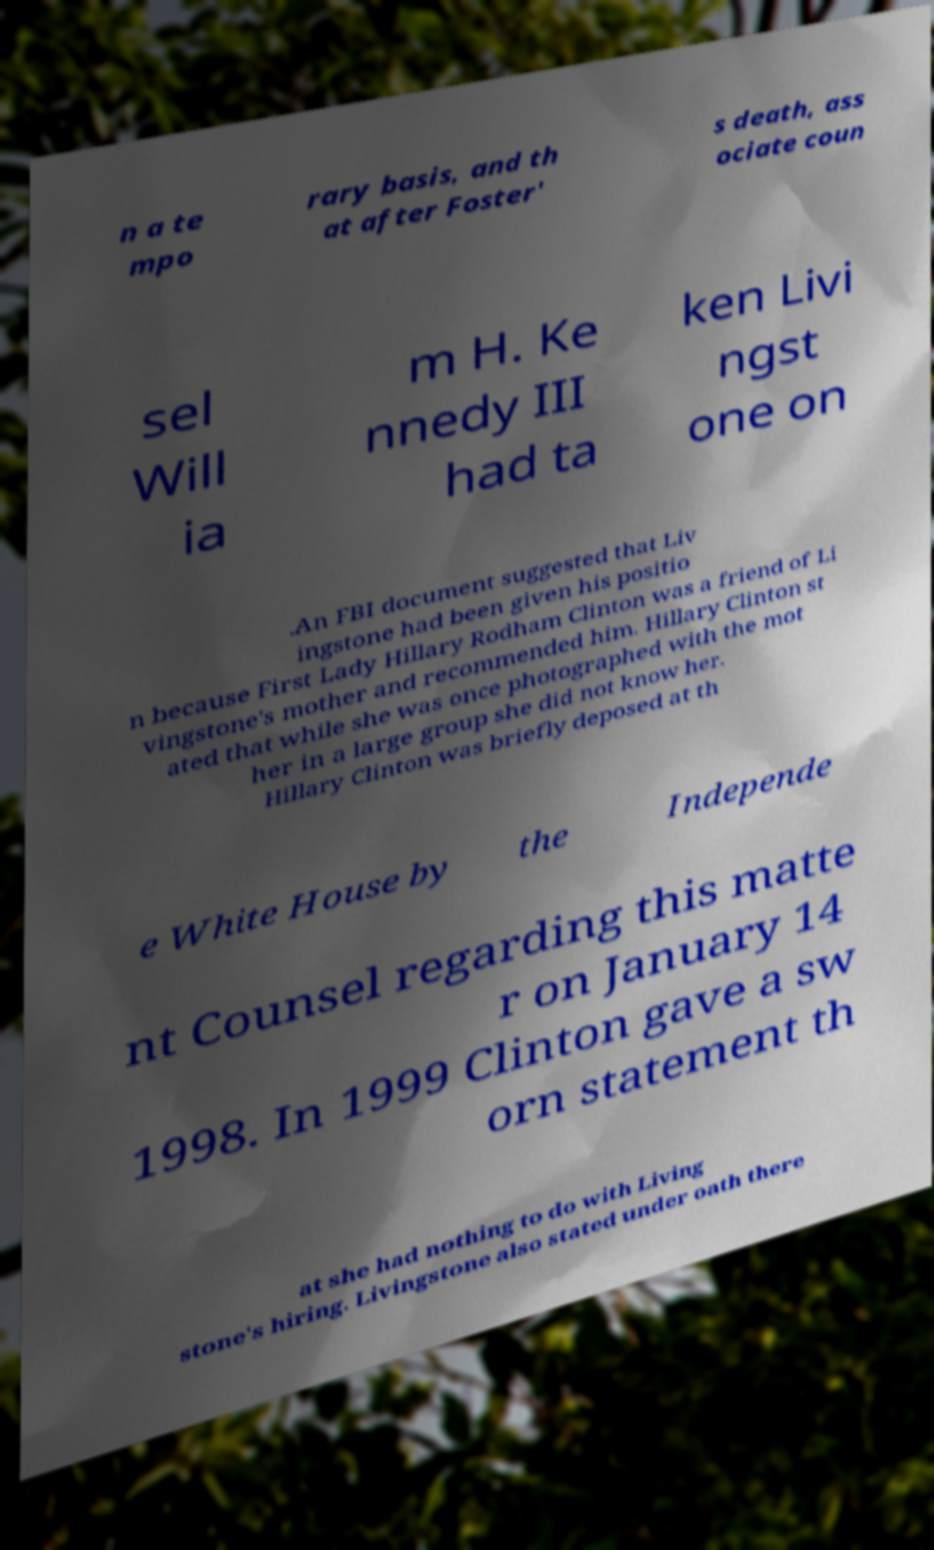Could you assist in decoding the text presented in this image and type it out clearly? n a te mpo rary basis, and th at after Foster' s death, ass ociate coun sel Will ia m H. Ke nnedy III had ta ken Livi ngst one on .An FBI document suggested that Liv ingstone had been given his positio n because First Lady Hillary Rodham Clinton was a friend of Li vingstone's mother and recommended him. Hillary Clinton st ated that while she was once photographed with the mot her in a large group she did not know her. Hillary Clinton was briefly deposed at th e White House by the Independe nt Counsel regarding this matte r on January 14 1998. In 1999 Clinton gave a sw orn statement th at she had nothing to do with Living stone's hiring. Livingstone also stated under oath there 